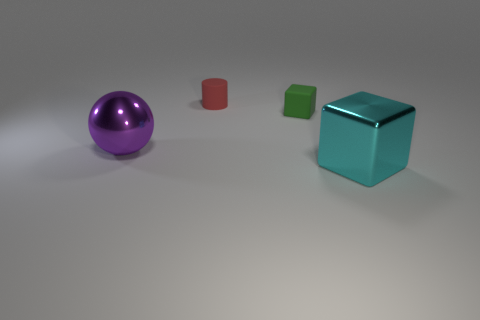Add 2 big cyan things. How many objects exist? 6 Subtract all cylinders. How many objects are left? 3 Add 4 red rubber things. How many red rubber things are left? 5 Add 2 large purple balls. How many large purple balls exist? 3 Subtract 1 purple spheres. How many objects are left? 3 Subtract all big cyan matte objects. Subtract all small rubber blocks. How many objects are left? 3 